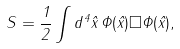<formula> <loc_0><loc_0><loc_500><loc_500>S = \frac { 1 } { 2 } \int d ^ { 4 } { \hat { x } } \, \Phi ( { \hat { x } } ) \square \Phi ( { \hat { x } } ) ,</formula> 